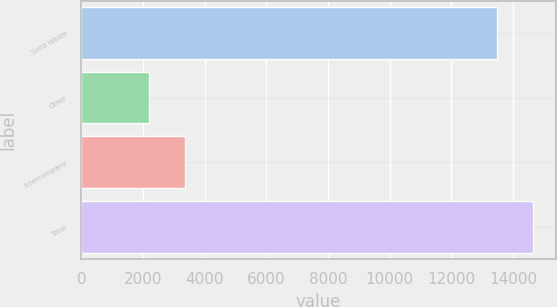<chart> <loc_0><loc_0><loc_500><loc_500><bar_chart><fcel>Solid Waste<fcel>Other<fcel>Intercompany<fcel>Total<nl><fcel>13477<fcel>2185<fcel>3364.8<fcel>14656.8<nl></chart> 